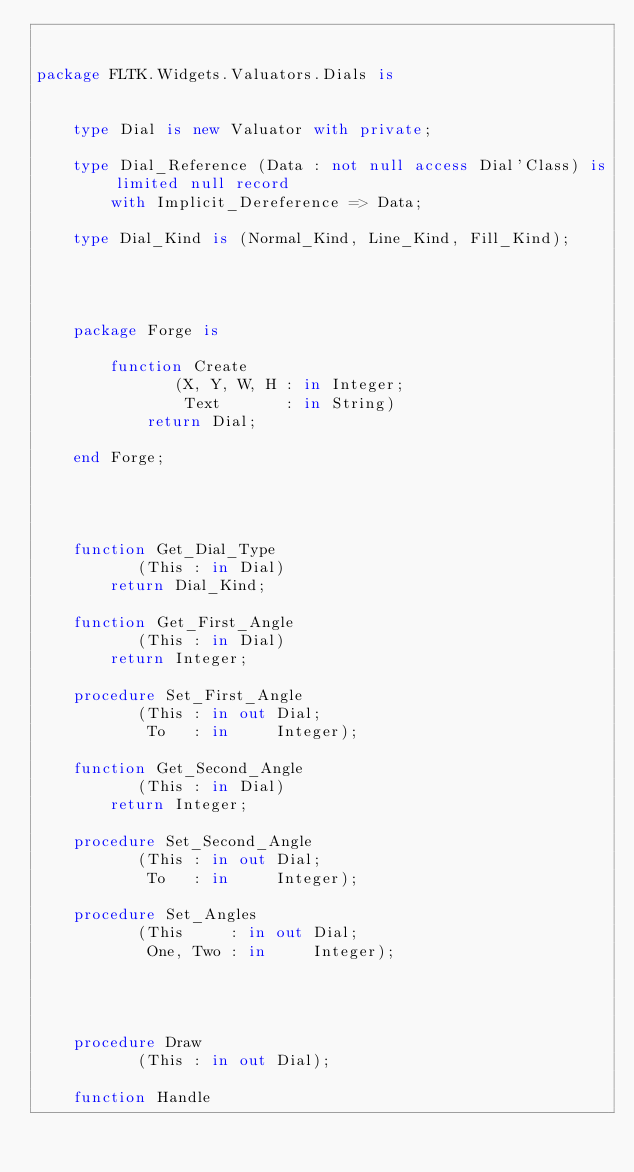<code> <loc_0><loc_0><loc_500><loc_500><_Ada_>

package FLTK.Widgets.Valuators.Dials is


    type Dial is new Valuator with private;

    type Dial_Reference (Data : not null access Dial'Class) is limited null record
        with Implicit_Dereference => Data;

    type Dial_Kind is (Normal_Kind, Line_Kind, Fill_Kind);




    package Forge is

        function Create
               (X, Y, W, H : in Integer;
                Text       : in String)
            return Dial;

    end Forge;




    function Get_Dial_Type
           (This : in Dial)
        return Dial_Kind;

    function Get_First_Angle
           (This : in Dial)
        return Integer;

    procedure Set_First_Angle
           (This : in out Dial;
            To   : in     Integer);

    function Get_Second_Angle
           (This : in Dial)
        return Integer;

    procedure Set_Second_Angle
           (This : in out Dial;
            To   : in     Integer);

    procedure Set_Angles
           (This     : in out Dial;
            One, Two : in     Integer);




    procedure Draw
           (This : in out Dial);

    function Handle</code> 